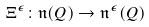<formula> <loc_0><loc_0><loc_500><loc_500>\Xi ^ { \epsilon } \colon \mathfrak { n } ( Q ) \rightarrow \mathfrak { n } ^ { \epsilon } ( Q )</formula> 